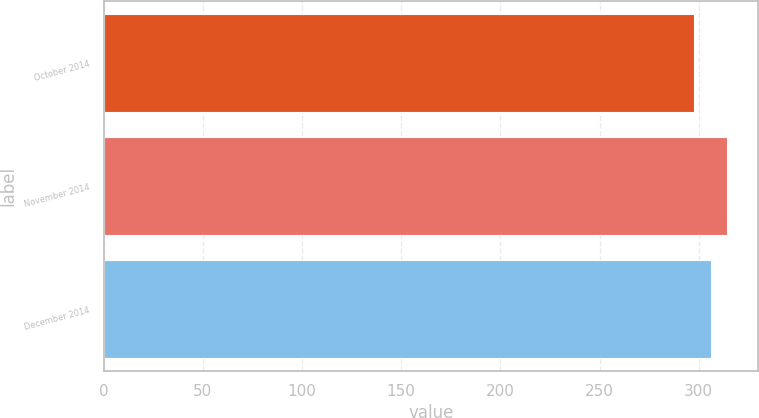<chart> <loc_0><loc_0><loc_500><loc_500><bar_chart><fcel>October 2014<fcel>November 2014<fcel>December 2014<nl><fcel>297.72<fcel>314.38<fcel>305.98<nl></chart> 